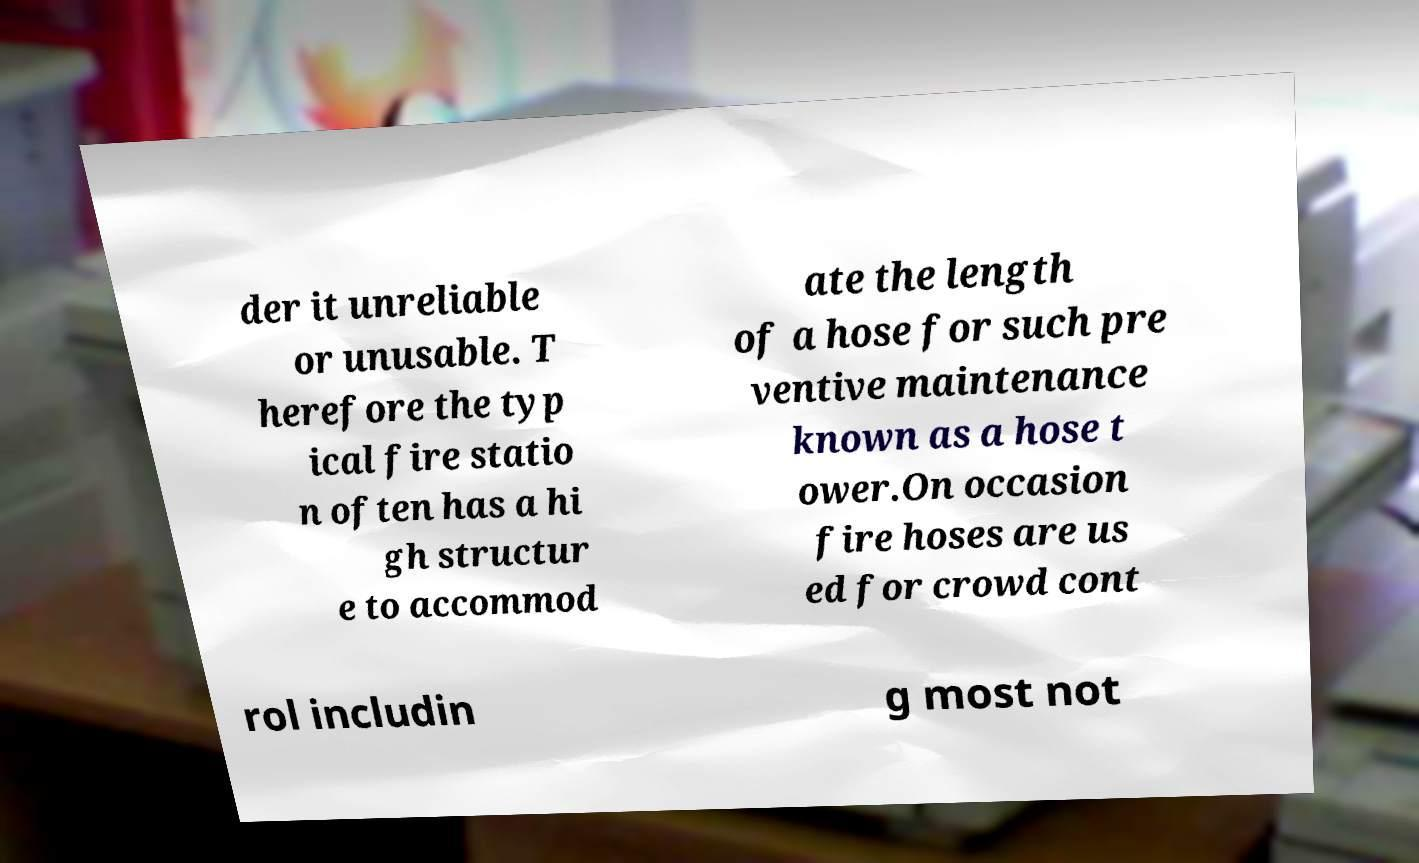There's text embedded in this image that I need extracted. Can you transcribe it verbatim? der it unreliable or unusable. T herefore the typ ical fire statio n often has a hi gh structur e to accommod ate the length of a hose for such pre ventive maintenance known as a hose t ower.On occasion fire hoses are us ed for crowd cont rol includin g most not 